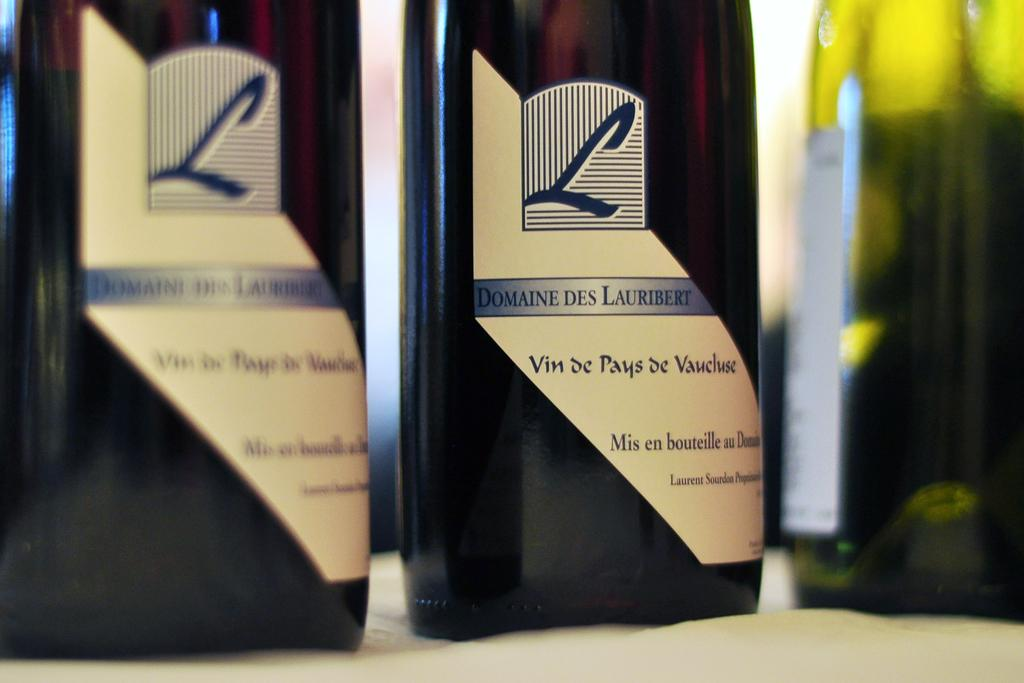How many bottles are visible in the image? There are three bottles in the image. What is the color of one of the bottles? One bottle is yellow. Are there any labels or text on the bottles? Yes, there is text written on two of the bottles. Reasoning: Let's think step by following the guidelines to produce the conversation. We start by identifying the main subject in the image, which is the three bottles. Then, we expand the conversation to include the color of one of the bottles and the presence of text on two of them. Each question is designed to elicit a specific detail about the image that is known from the provided facts. Absurd Question/Answer: What songs are being sung by the judge in the image? There is no judge or singing in the image; it only features three bottles. 